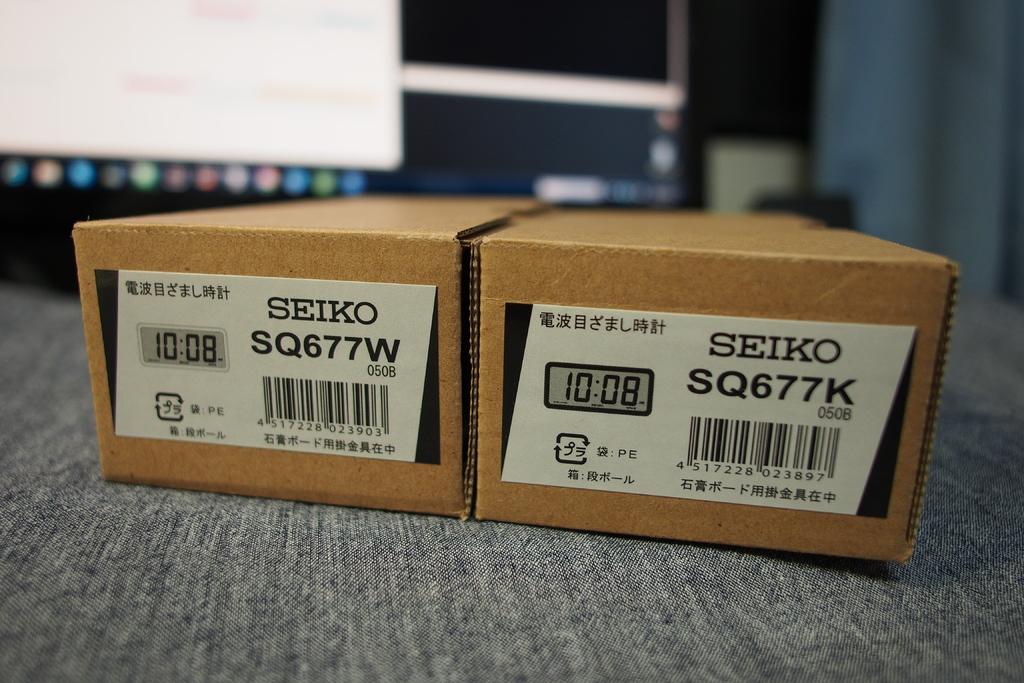What time is displayed on the two boxes?
Offer a very short reply. 10:08. 